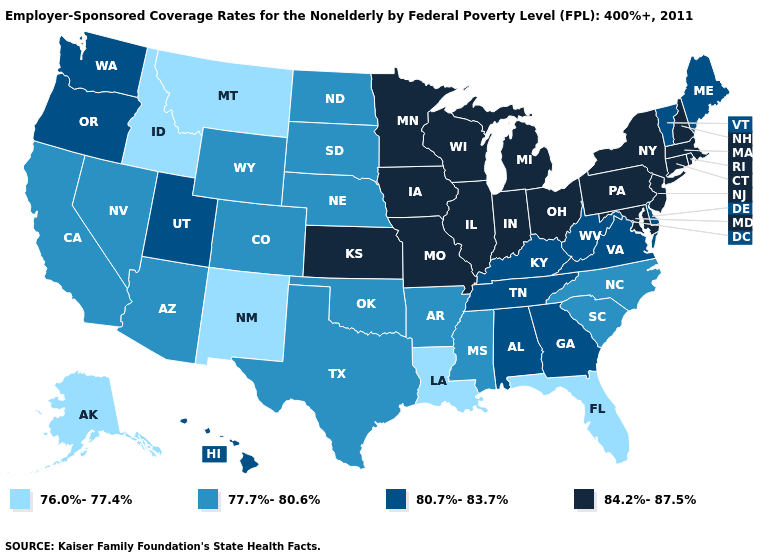Does New Hampshire have the highest value in the Northeast?
Give a very brief answer. Yes. How many symbols are there in the legend?
Keep it brief. 4. Does Iowa have a higher value than Louisiana?
Keep it brief. Yes. Name the states that have a value in the range 76.0%-77.4%?
Be succinct. Alaska, Florida, Idaho, Louisiana, Montana, New Mexico. Does Alaska have the lowest value in the USA?
Write a very short answer. Yes. Name the states that have a value in the range 80.7%-83.7%?
Quick response, please. Alabama, Delaware, Georgia, Hawaii, Kentucky, Maine, Oregon, Tennessee, Utah, Vermont, Virginia, Washington, West Virginia. Name the states that have a value in the range 77.7%-80.6%?
Concise answer only. Arizona, Arkansas, California, Colorado, Mississippi, Nebraska, Nevada, North Carolina, North Dakota, Oklahoma, South Carolina, South Dakota, Texas, Wyoming. How many symbols are there in the legend?
Keep it brief. 4. What is the value of Tennessee?
Give a very brief answer. 80.7%-83.7%. What is the value of Utah?
Answer briefly. 80.7%-83.7%. Name the states that have a value in the range 80.7%-83.7%?
Concise answer only. Alabama, Delaware, Georgia, Hawaii, Kentucky, Maine, Oregon, Tennessee, Utah, Vermont, Virginia, Washington, West Virginia. Name the states that have a value in the range 84.2%-87.5%?
Quick response, please. Connecticut, Illinois, Indiana, Iowa, Kansas, Maryland, Massachusetts, Michigan, Minnesota, Missouri, New Hampshire, New Jersey, New York, Ohio, Pennsylvania, Rhode Island, Wisconsin. What is the value of Montana?
Concise answer only. 76.0%-77.4%. Name the states that have a value in the range 76.0%-77.4%?
Be succinct. Alaska, Florida, Idaho, Louisiana, Montana, New Mexico. Does South Carolina have a lower value than Connecticut?
Quick response, please. Yes. 